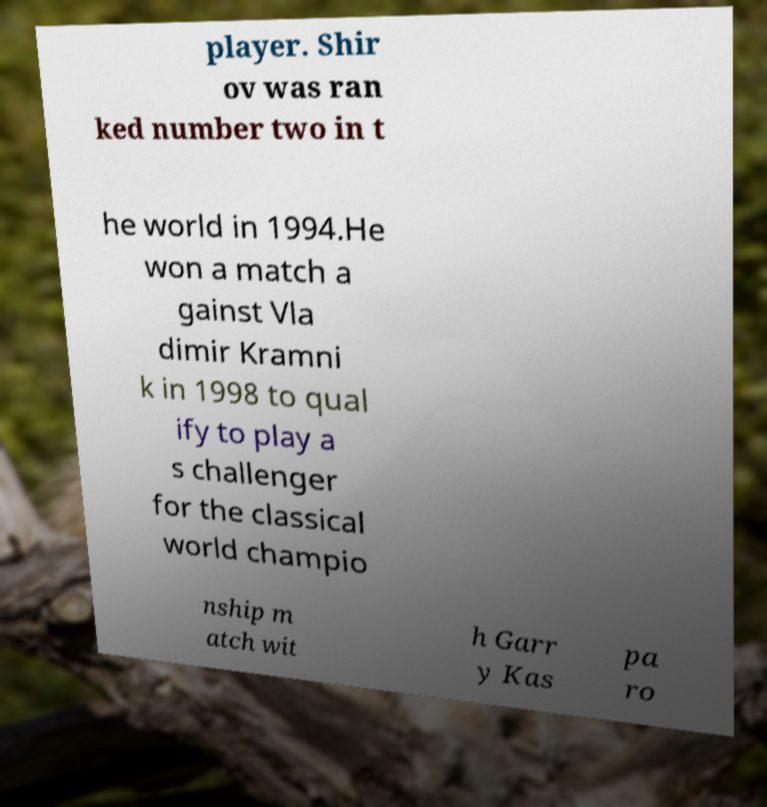Please identify and transcribe the text found in this image. player. Shir ov was ran ked number two in t he world in 1994.He won a match a gainst Vla dimir Kramni k in 1998 to qual ify to play a s challenger for the classical world champio nship m atch wit h Garr y Kas pa ro 